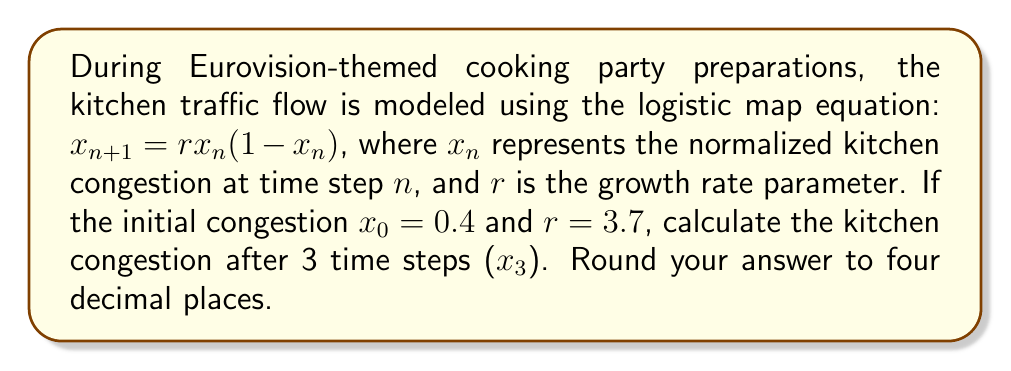Provide a solution to this math problem. To solve this problem, we need to iterate the logistic map equation three times:

Step 1: Calculate $x_1$
$$x_1 = r \cdot x_0 \cdot (1 - x_0)$$
$$x_1 = 3.7 \cdot 0.4 \cdot (1 - 0.4)$$
$$x_1 = 3.7 \cdot 0.4 \cdot 0.6 = 0.888$$

Step 2: Calculate $x_2$
$$x_2 = r \cdot x_1 \cdot (1 - x_1)$$
$$x_2 = 3.7 \cdot 0.888 \cdot (1 - 0.888)$$
$$x_2 = 3.7 \cdot 0.888 \cdot 0.112 = 0.3682752$$

Step 3: Calculate $x_3$
$$x_3 = r \cdot x_2 \cdot (1 - x_2)$$
$$x_3 = 3.7 \cdot 0.3682752 \cdot (1 - 0.3682752)$$
$$x_3 = 3.7 \cdot 0.3682752 \cdot 0.6317248 = 0.8630471$$

Step 4: Round to four decimal places
$$x_3 \approx 0.8630$$
Answer: 0.8630 